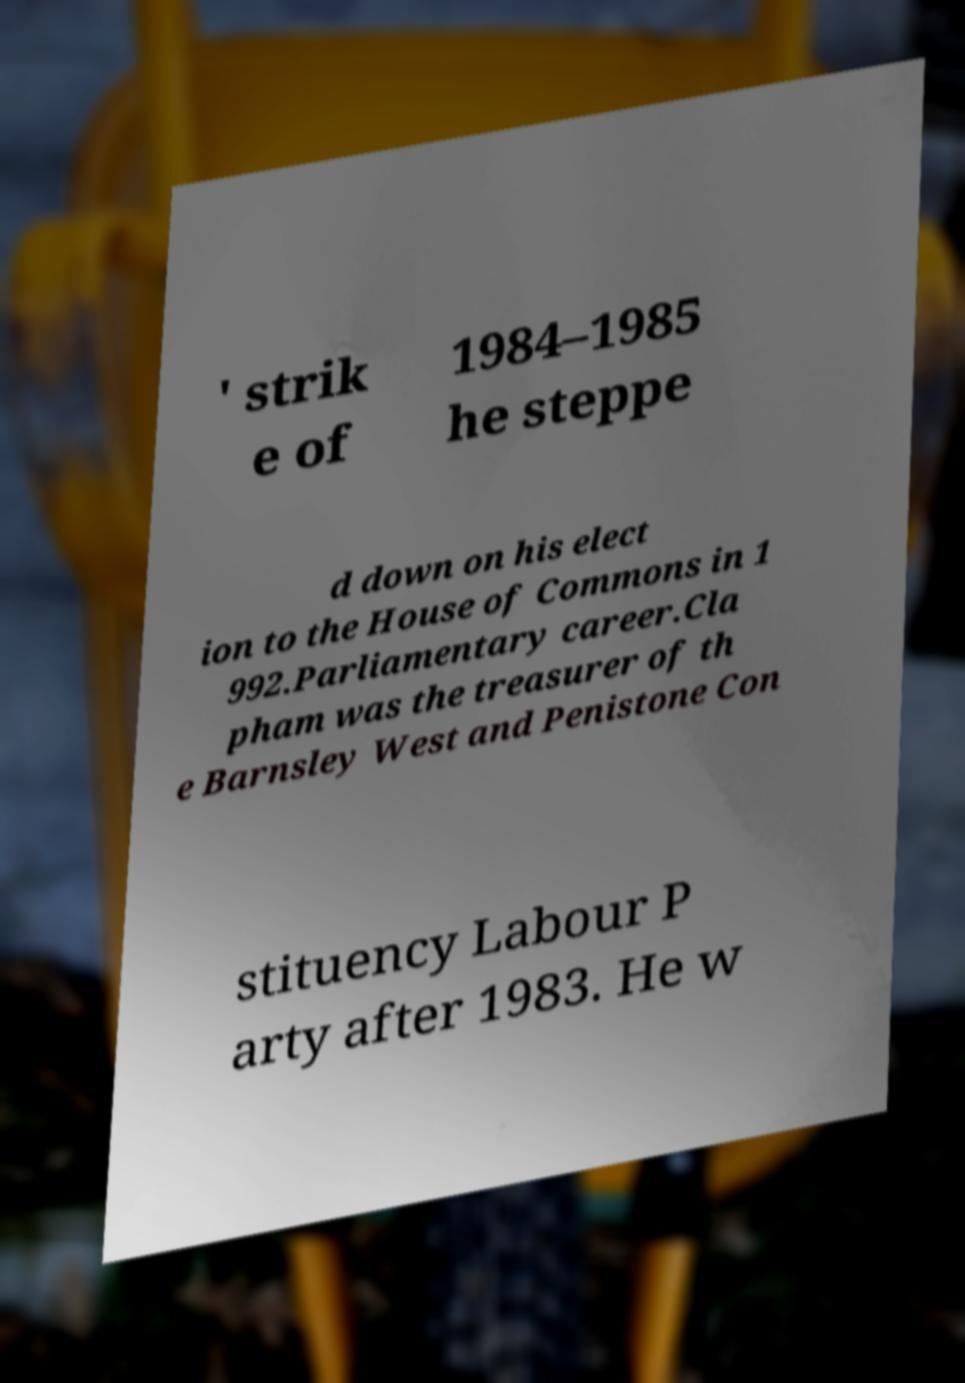Could you assist in decoding the text presented in this image and type it out clearly? ' strik e of 1984–1985 he steppe d down on his elect ion to the House of Commons in 1 992.Parliamentary career.Cla pham was the treasurer of th e Barnsley West and Penistone Con stituency Labour P arty after 1983. He w 